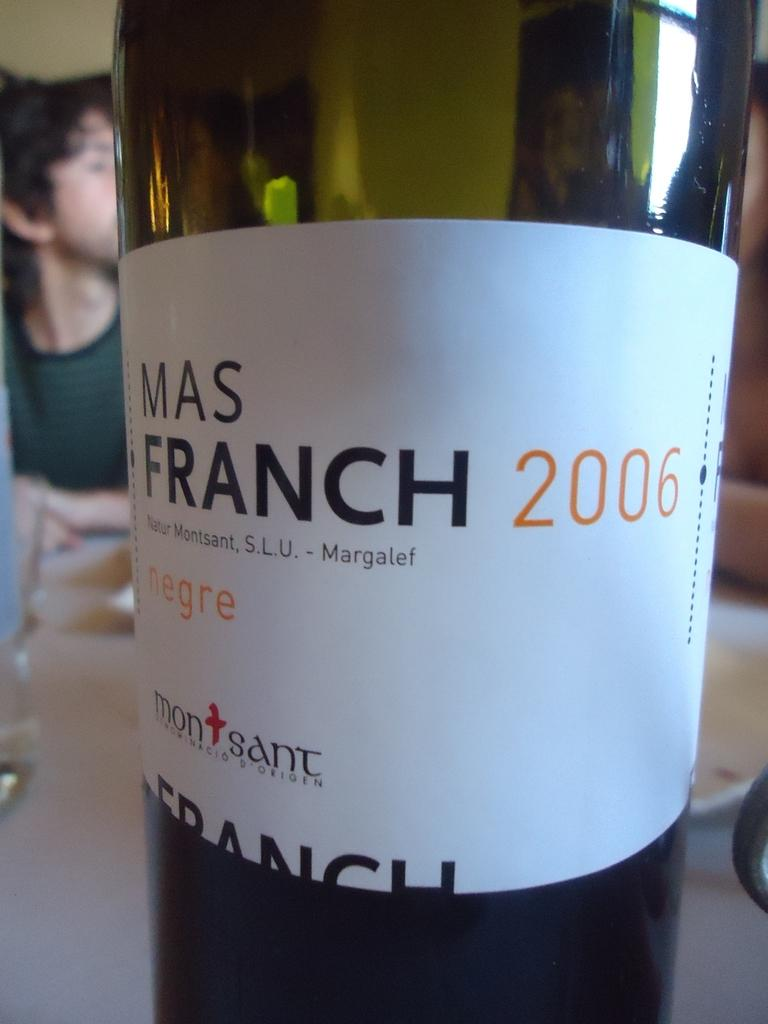<image>
Relay a brief, clear account of the picture shown. A bottle of Mas Franch 2006 sitting on a table. 